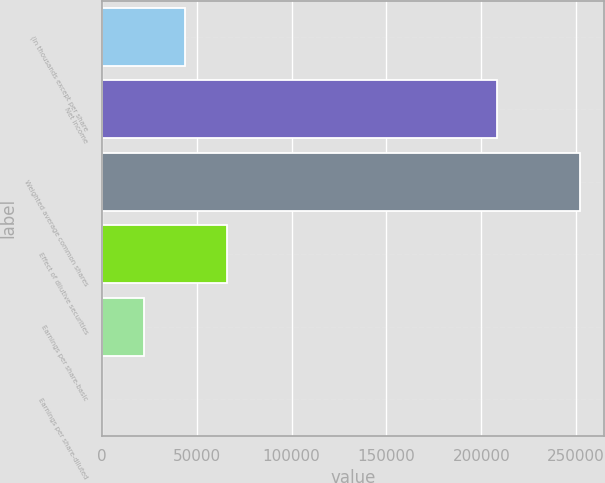<chart> <loc_0><loc_0><loc_500><loc_500><bar_chart><fcel>(In thousands except per share<fcel>Net income<fcel>Weighted average common shares<fcel>Effect of dilutive securities<fcel>Earnings per share-basic<fcel>Earnings per share-diluted<nl><fcel>43876.8<fcel>208042<fcel>251918<fcel>65814.6<fcel>21938.8<fcel>0.95<nl></chart> 